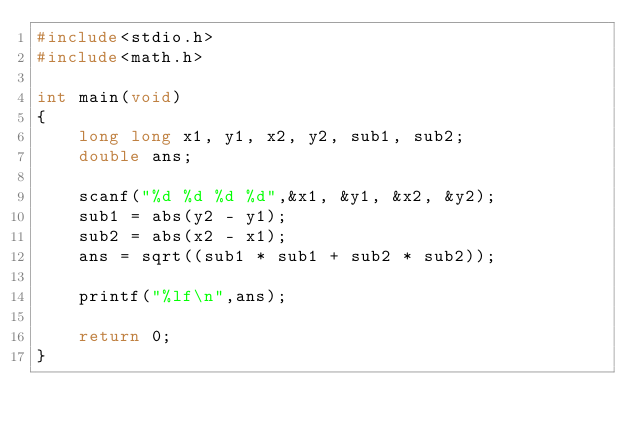Convert code to text. <code><loc_0><loc_0><loc_500><loc_500><_C_>#include<stdio.h>
#include<math.h>

int main(void)
{
	long long x1, y1, x2, y2, sub1, sub2;
	double ans;

	scanf("%d %d %d %d",&x1, &y1, &x2, &y2);
	sub1 = abs(y2 - y1);
	sub2 = abs(x2 - x1);
	ans = sqrt((sub1 * sub1 + sub2 * sub2));

	printf("%lf\n",ans);

	return 0;
}</code> 